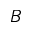Convert formula to latex. <formula><loc_0><loc_0><loc_500><loc_500>B</formula> 